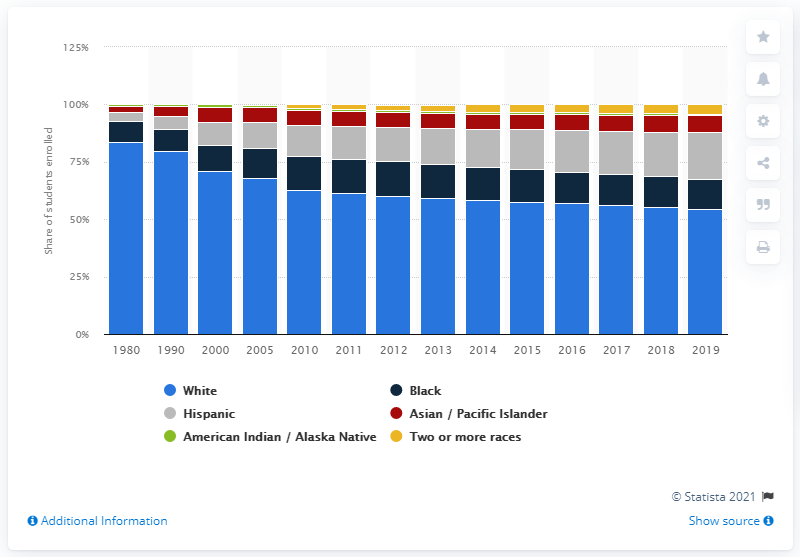Specify some key components in this picture. White students make up more than half of postsecondary students. According to a recent study, approximately 54.3% of postsecondary students are white. 